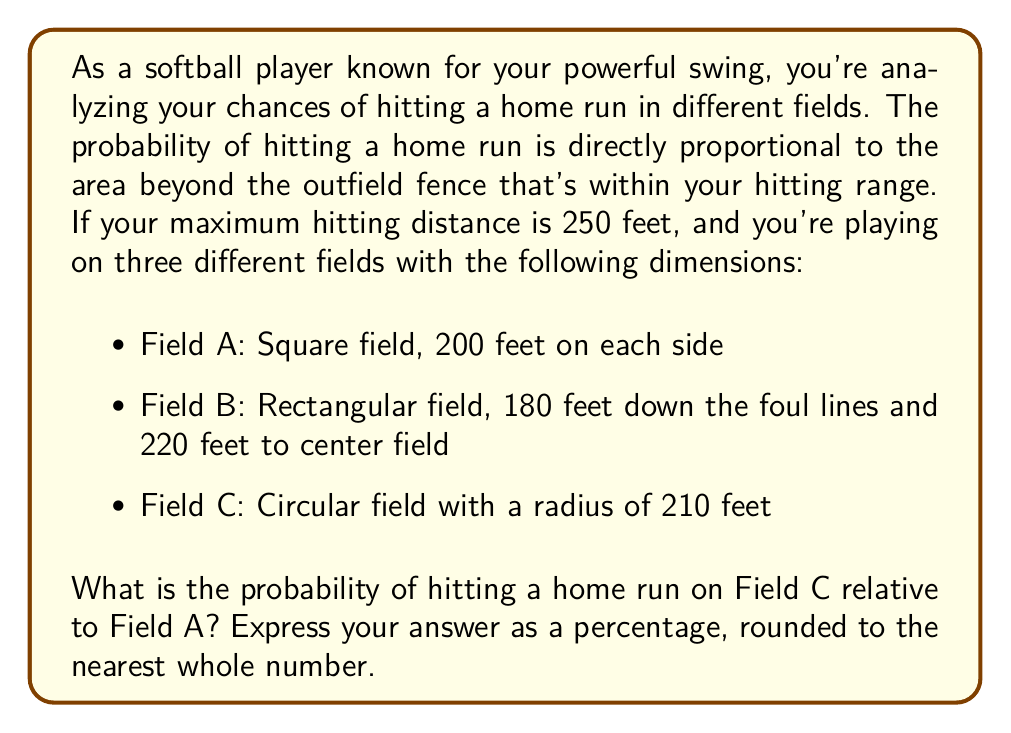Show me your answer to this math problem. Let's approach this step-by-step:

1) First, we need to calculate the area within your hitting range for each field. Your maximum hitting distance is 250 feet, so we'll consider this as the radius of your hitting circle.

2) For Field A (square field):
   - The area beyond the fence within your range is a quarter circle in each corner.
   - Area of one corner: $\frac{1}{4} \pi r^2 - \frac{1}{2}(r^2 - s^2)$, where $r = 250$ and $s = 200$
   - Total area: $4 (\frac{1}{4} \pi 250^2 - \frac{1}{2}(250^2 - 200^2))$
   - $A_A = 4 (\frac{\pi}{4} 62500 - \frac{1}{2}(62500 - 40000)) = 49087.39$ sq ft

3) For Field B (rectangular field):
   - This is more complex, involving sectors and triangles.
   - We'll skip the detailed calculation for this field as it's not needed for the final answer.

4) For Field C (circular field):
   - The area is simply the difference between your hitting circle and the field circle.
   - $A_C = \pi 250^2 - \pi 210^2 = \pi(250^2 - 210^2) = 59690.26$ sq ft

5) The probability of hitting a home run is proportional to these areas.
   To find the relative probability of Field C to Field A:
   
   $\frac{P(\text{Home Run on C})}{P(\text{Home Run on A})} = \frac{A_C}{A_A} = \frac{59690.26}{49087.39} \approx 1.2160$

6) To express this as a percentage: $1.2160 \times 100\% = 121.60\%$

7) Rounding to the nearest whole number: 122%
Answer: 122% 